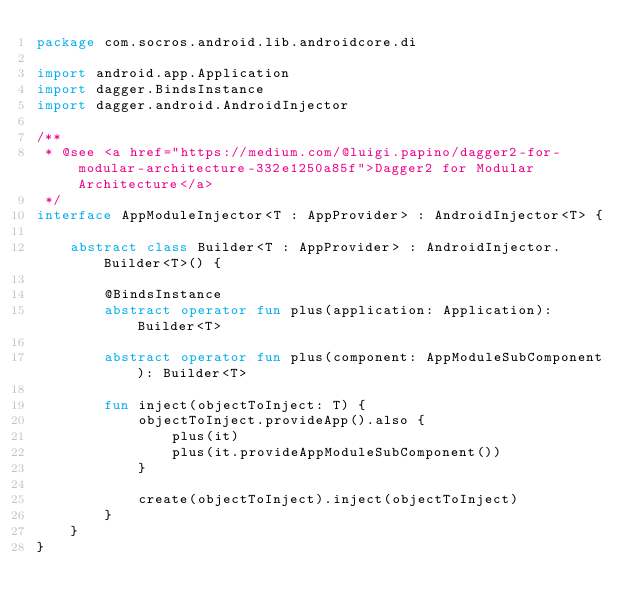<code> <loc_0><loc_0><loc_500><loc_500><_Kotlin_>package com.socros.android.lib.androidcore.di

import android.app.Application
import dagger.BindsInstance
import dagger.android.AndroidInjector

/**
 * @see <a href="https://medium.com/@luigi.papino/dagger2-for-modular-architecture-332e1250a85f">Dagger2 for Modular Architecture</a>
 */
interface AppModuleInjector<T : AppProvider> : AndroidInjector<T> {

	abstract class Builder<T : AppProvider> : AndroidInjector.Builder<T>() {

		@BindsInstance
		abstract operator fun plus(application: Application): Builder<T>

		abstract operator fun plus(component: AppModuleSubComponent): Builder<T>

		fun inject(objectToInject: T) {
			objectToInject.provideApp().also {
				plus(it)
				plus(it.provideAppModuleSubComponent())
			}

			create(objectToInject).inject(objectToInject)
		}
	}
}
</code> 